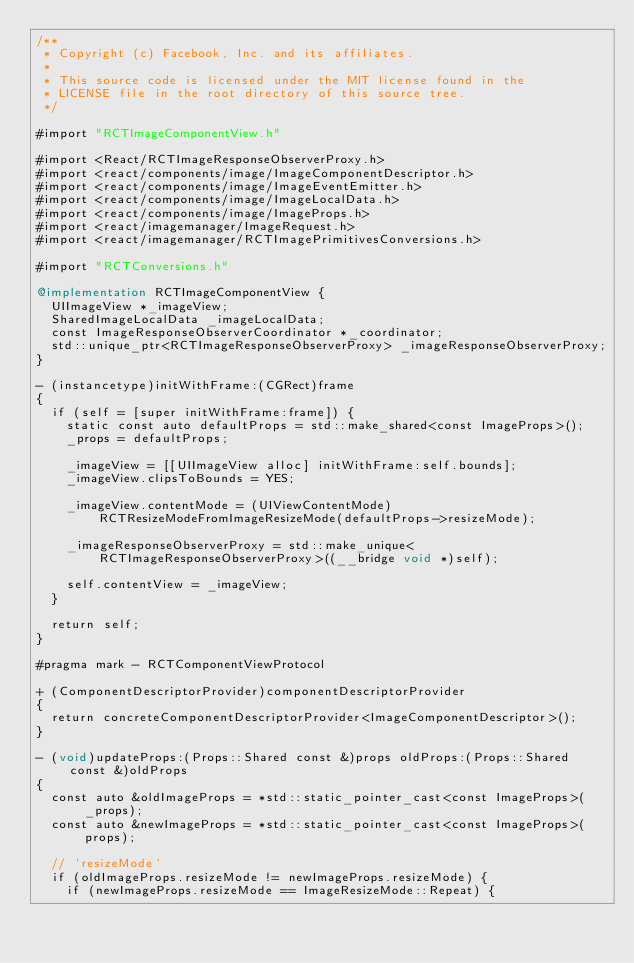Convert code to text. <code><loc_0><loc_0><loc_500><loc_500><_ObjectiveC_>/**
 * Copyright (c) Facebook, Inc. and its affiliates.
 *
 * This source code is licensed under the MIT license found in the
 * LICENSE file in the root directory of this source tree.
 */

#import "RCTImageComponentView.h"

#import <React/RCTImageResponseObserverProxy.h>
#import <react/components/image/ImageComponentDescriptor.h>
#import <react/components/image/ImageEventEmitter.h>
#import <react/components/image/ImageLocalData.h>
#import <react/components/image/ImageProps.h>
#import <react/imagemanager/ImageRequest.h>
#import <react/imagemanager/RCTImagePrimitivesConversions.h>

#import "RCTConversions.h"

@implementation RCTImageComponentView {
  UIImageView *_imageView;
  SharedImageLocalData _imageLocalData;
  const ImageResponseObserverCoordinator *_coordinator;
  std::unique_ptr<RCTImageResponseObserverProxy> _imageResponseObserverProxy;
}

- (instancetype)initWithFrame:(CGRect)frame
{
  if (self = [super initWithFrame:frame]) {
    static const auto defaultProps = std::make_shared<const ImageProps>();
    _props = defaultProps;

    _imageView = [[UIImageView alloc] initWithFrame:self.bounds];
    _imageView.clipsToBounds = YES;

    _imageView.contentMode = (UIViewContentMode)RCTResizeModeFromImageResizeMode(defaultProps->resizeMode);

    _imageResponseObserverProxy = std::make_unique<RCTImageResponseObserverProxy>((__bridge void *)self);

    self.contentView = _imageView;
  }

  return self;
}

#pragma mark - RCTComponentViewProtocol

+ (ComponentDescriptorProvider)componentDescriptorProvider
{
  return concreteComponentDescriptorProvider<ImageComponentDescriptor>();
}

- (void)updateProps:(Props::Shared const &)props oldProps:(Props::Shared const &)oldProps
{
  const auto &oldImageProps = *std::static_pointer_cast<const ImageProps>(_props);
  const auto &newImageProps = *std::static_pointer_cast<const ImageProps>(props);

  // `resizeMode`
  if (oldImageProps.resizeMode != newImageProps.resizeMode) {
    if (newImageProps.resizeMode == ImageResizeMode::Repeat) {</code> 